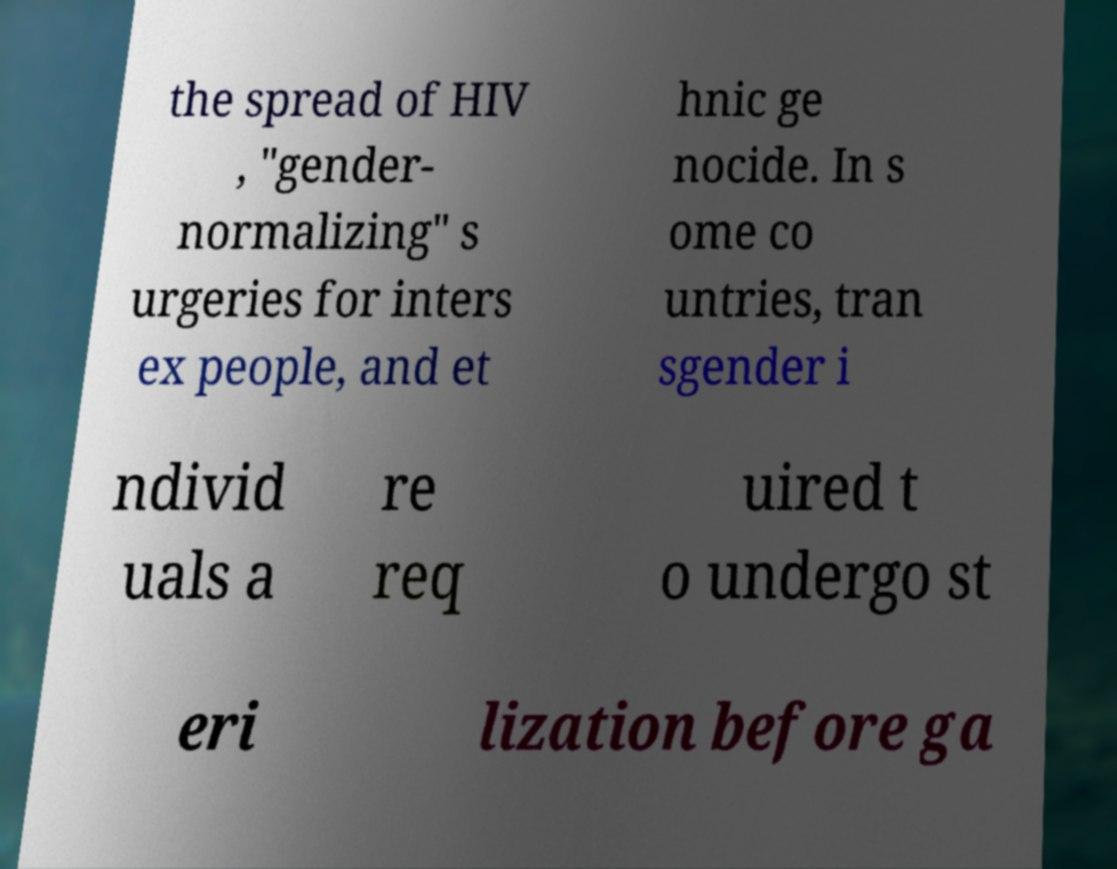What messages or text are displayed in this image? I need them in a readable, typed format. the spread of HIV , "gender- normalizing" s urgeries for inters ex people, and et hnic ge nocide. In s ome co untries, tran sgender i ndivid uals a re req uired t o undergo st eri lization before ga 